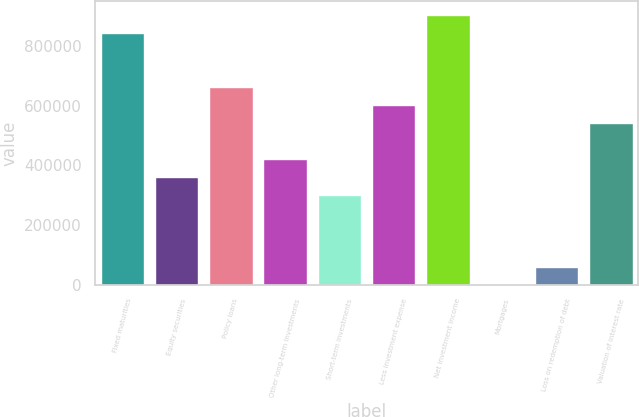Convert chart to OTSL. <chart><loc_0><loc_0><loc_500><loc_500><bar_chart><fcel>Fixed maturities<fcel>Equity securities<fcel>Policy loans<fcel>Other long-term investments<fcel>Short-term investments<fcel>Less investment expense<fcel>Net investment income<fcel>Mortgages<fcel>Loss on redemption of debt<fcel>Valuation of interest rate<nl><fcel>844294<fcel>361842<fcel>663375<fcel>422148<fcel>301535<fcel>603068<fcel>904601<fcel>2.41<fcel>60309<fcel>542761<nl></chart> 